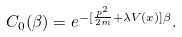Convert formula to latex. <formula><loc_0><loc_0><loc_500><loc_500>C _ { 0 } ( \beta ) = e ^ { - [ \frac { p ^ { 2 } } { 2 m } + \lambda V ( x ) ] \beta } .</formula> 